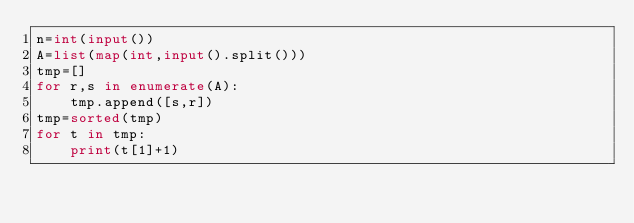Convert code to text. <code><loc_0><loc_0><loc_500><loc_500><_Python_>n=int(input())
A=list(map(int,input().split()))
tmp=[]
for r,s in enumerate(A):
    tmp.append([s,r])
tmp=sorted(tmp)
for t in tmp:
    print(t[1]+1)</code> 